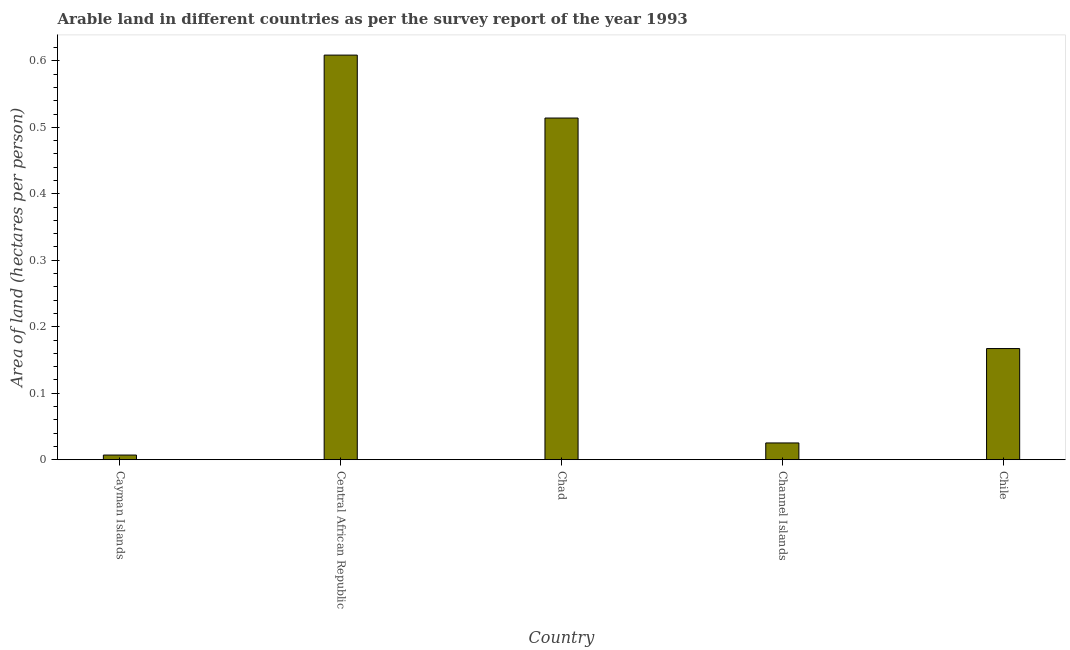Does the graph contain any zero values?
Offer a very short reply. No. What is the title of the graph?
Give a very brief answer. Arable land in different countries as per the survey report of the year 1993. What is the label or title of the Y-axis?
Keep it short and to the point. Area of land (hectares per person). What is the area of arable land in Chad?
Make the answer very short. 0.51. Across all countries, what is the maximum area of arable land?
Provide a succinct answer. 0.61. Across all countries, what is the minimum area of arable land?
Keep it short and to the point. 0.01. In which country was the area of arable land maximum?
Your answer should be compact. Central African Republic. In which country was the area of arable land minimum?
Ensure brevity in your answer.  Cayman Islands. What is the sum of the area of arable land?
Ensure brevity in your answer.  1.32. What is the difference between the area of arable land in Cayman Islands and Chad?
Give a very brief answer. -0.51. What is the average area of arable land per country?
Provide a succinct answer. 0.26. What is the median area of arable land?
Your answer should be compact. 0.17. In how many countries, is the area of arable land greater than 0.6 hectares per person?
Offer a terse response. 1. What is the ratio of the area of arable land in Channel Islands to that in Chile?
Your response must be concise. 0.15. Is the area of arable land in Central African Republic less than that in Chile?
Your answer should be compact. No. What is the difference between the highest and the second highest area of arable land?
Give a very brief answer. 0.1. In how many countries, is the area of arable land greater than the average area of arable land taken over all countries?
Ensure brevity in your answer.  2. How many bars are there?
Make the answer very short. 5. What is the Area of land (hectares per person) of Cayman Islands?
Provide a short and direct response. 0.01. What is the Area of land (hectares per person) of Central African Republic?
Keep it short and to the point. 0.61. What is the Area of land (hectares per person) in Chad?
Your answer should be compact. 0.51. What is the Area of land (hectares per person) of Channel Islands?
Give a very brief answer. 0.03. What is the Area of land (hectares per person) of Chile?
Your answer should be very brief. 0.17. What is the difference between the Area of land (hectares per person) in Cayman Islands and Central African Republic?
Ensure brevity in your answer.  -0.6. What is the difference between the Area of land (hectares per person) in Cayman Islands and Chad?
Your response must be concise. -0.51. What is the difference between the Area of land (hectares per person) in Cayman Islands and Channel Islands?
Offer a terse response. -0.02. What is the difference between the Area of land (hectares per person) in Cayman Islands and Chile?
Provide a short and direct response. -0.16. What is the difference between the Area of land (hectares per person) in Central African Republic and Chad?
Provide a short and direct response. 0.09. What is the difference between the Area of land (hectares per person) in Central African Republic and Channel Islands?
Provide a short and direct response. 0.58. What is the difference between the Area of land (hectares per person) in Central African Republic and Chile?
Ensure brevity in your answer.  0.44. What is the difference between the Area of land (hectares per person) in Chad and Channel Islands?
Make the answer very short. 0.49. What is the difference between the Area of land (hectares per person) in Chad and Chile?
Give a very brief answer. 0.35. What is the difference between the Area of land (hectares per person) in Channel Islands and Chile?
Provide a short and direct response. -0.14. What is the ratio of the Area of land (hectares per person) in Cayman Islands to that in Central African Republic?
Offer a very short reply. 0.01. What is the ratio of the Area of land (hectares per person) in Cayman Islands to that in Chad?
Keep it short and to the point. 0.01. What is the ratio of the Area of land (hectares per person) in Cayman Islands to that in Channel Islands?
Keep it short and to the point. 0.28. What is the ratio of the Area of land (hectares per person) in Cayman Islands to that in Chile?
Your answer should be compact. 0.04. What is the ratio of the Area of land (hectares per person) in Central African Republic to that in Chad?
Give a very brief answer. 1.18. What is the ratio of the Area of land (hectares per person) in Central African Republic to that in Channel Islands?
Give a very brief answer. 24.15. What is the ratio of the Area of land (hectares per person) in Central African Republic to that in Chile?
Your answer should be very brief. 3.64. What is the ratio of the Area of land (hectares per person) in Chad to that in Channel Islands?
Offer a very short reply. 20.39. What is the ratio of the Area of land (hectares per person) in Chad to that in Chile?
Ensure brevity in your answer.  3.07. What is the ratio of the Area of land (hectares per person) in Channel Islands to that in Chile?
Your answer should be compact. 0.15. 